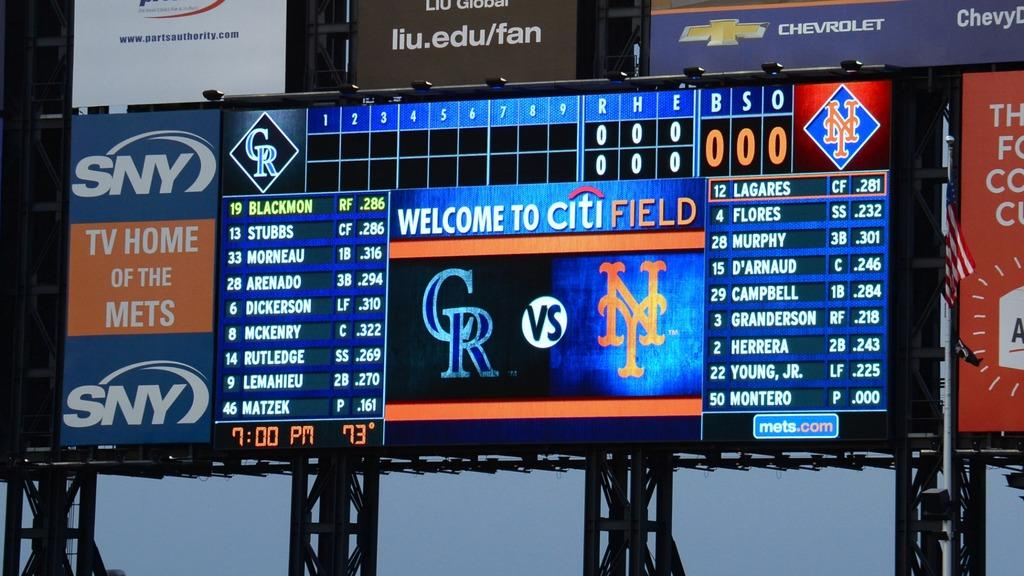Provide a one-sentence caption for the provided image. A sign says "welcome to Citi Field" and shows which teams are playing. 